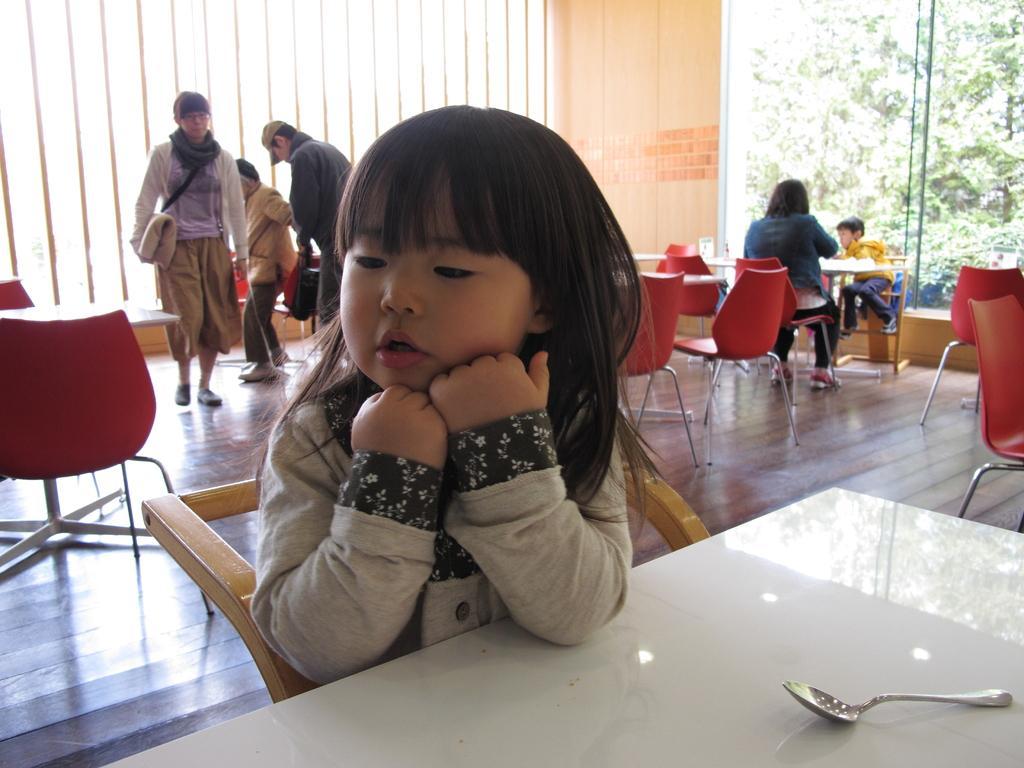In one or two sentences, can you explain what this image depicts? In this image I can see a girl is sitting. I can also see a spoon on this table. In the background I can see few more people where few of them are standing and few are sitting on chairs. Here I can see number of chairs and tables. 